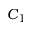<formula> <loc_0><loc_0><loc_500><loc_500>C _ { 1 }</formula> 